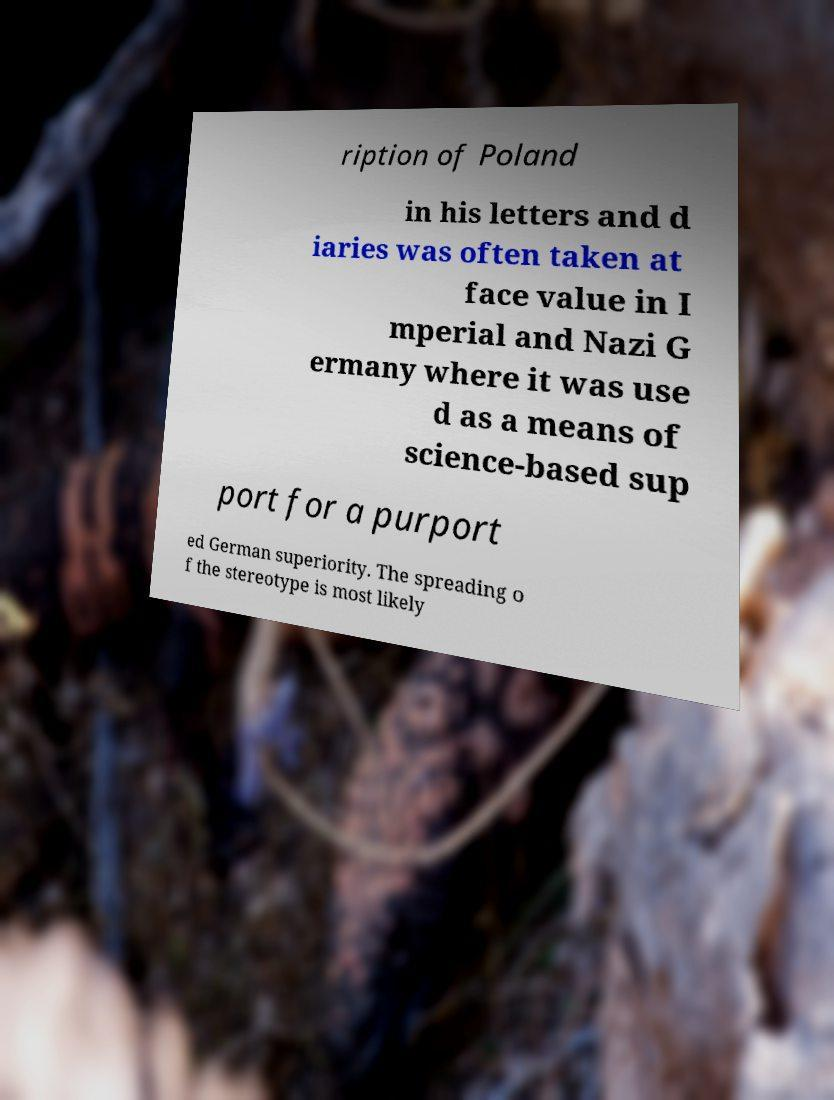Could you assist in decoding the text presented in this image and type it out clearly? ription of Poland in his letters and d iaries was often taken at face value in I mperial and Nazi G ermany where it was use d as a means of science-based sup port for a purport ed German superiority. The spreading o f the stereotype is most likely 